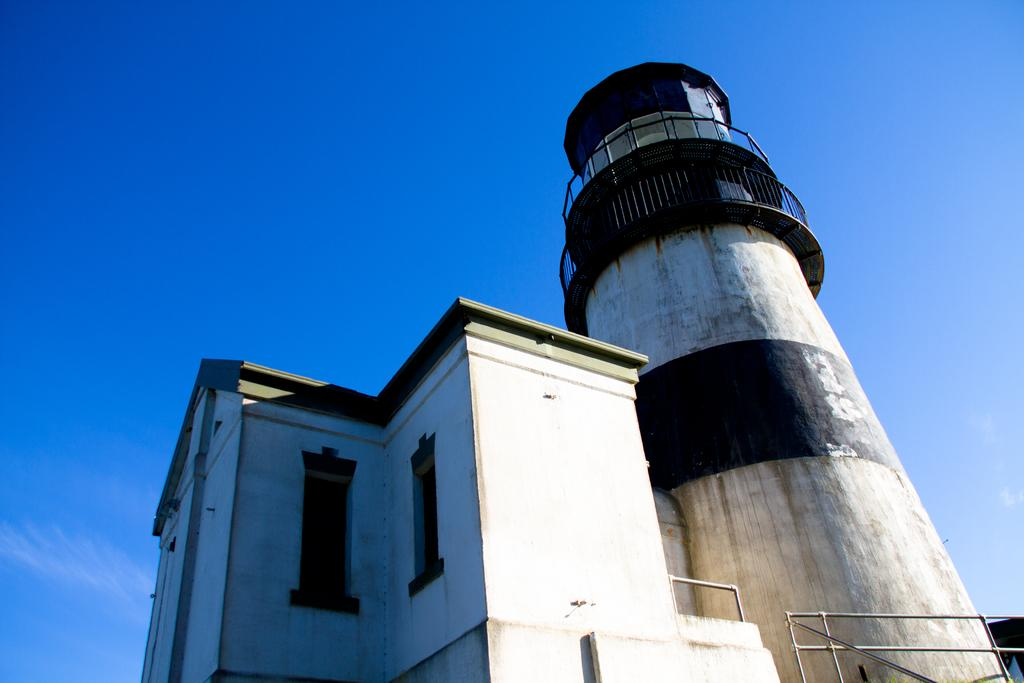What type of structures can be seen in the image? There are buildings in the image. What feature is present on the buildings or nearby? There are railings in the image. What is visible at the top of the image? The sky is visible at the top of the image. Can you see any stitches on the railings in the image? There is no mention of stitches or any specific details about the railings in the image, so we cannot determine if stitches are present. 